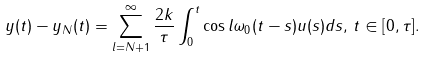<formula> <loc_0><loc_0><loc_500><loc_500>y ( t ) - y _ { N } ( t ) = \sum _ { l = N + 1 } ^ { \infty } \frac { 2 k } { \tau } \int _ { 0 } ^ { t } \cos l \omega _ { 0 } ( t - s ) u ( s ) d s , \, t \in [ 0 , \tau ] .</formula> 